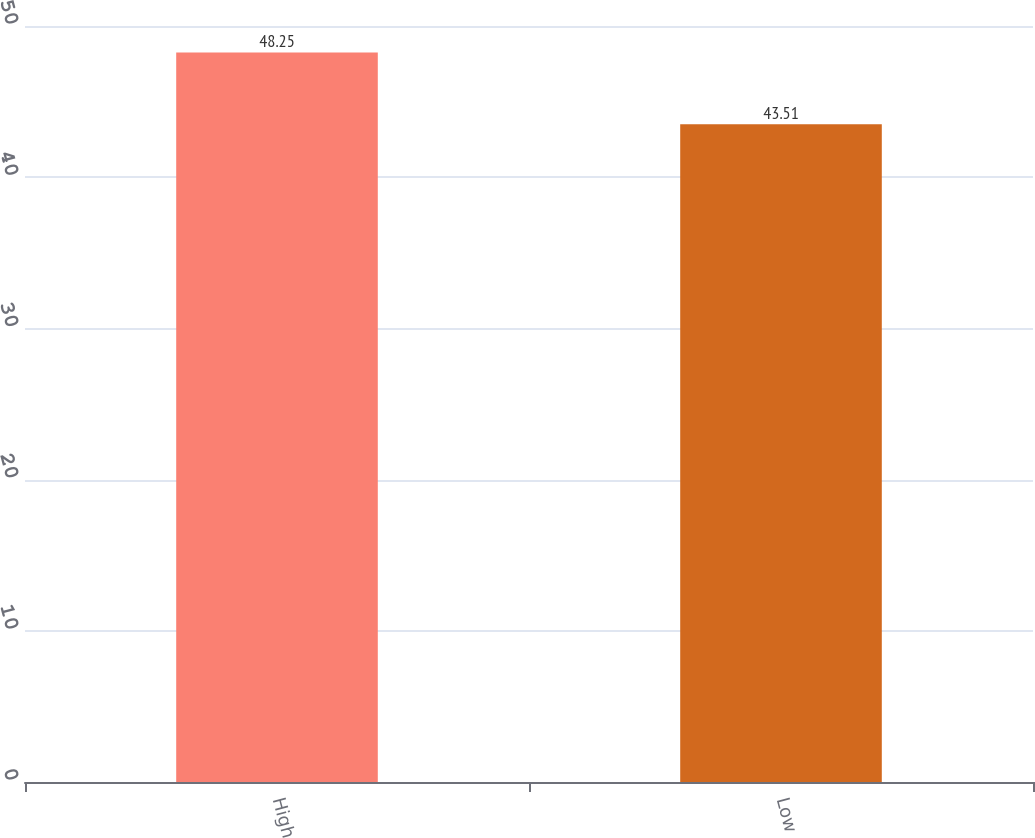Convert chart to OTSL. <chart><loc_0><loc_0><loc_500><loc_500><bar_chart><fcel>High<fcel>Low<nl><fcel>48.25<fcel>43.51<nl></chart> 